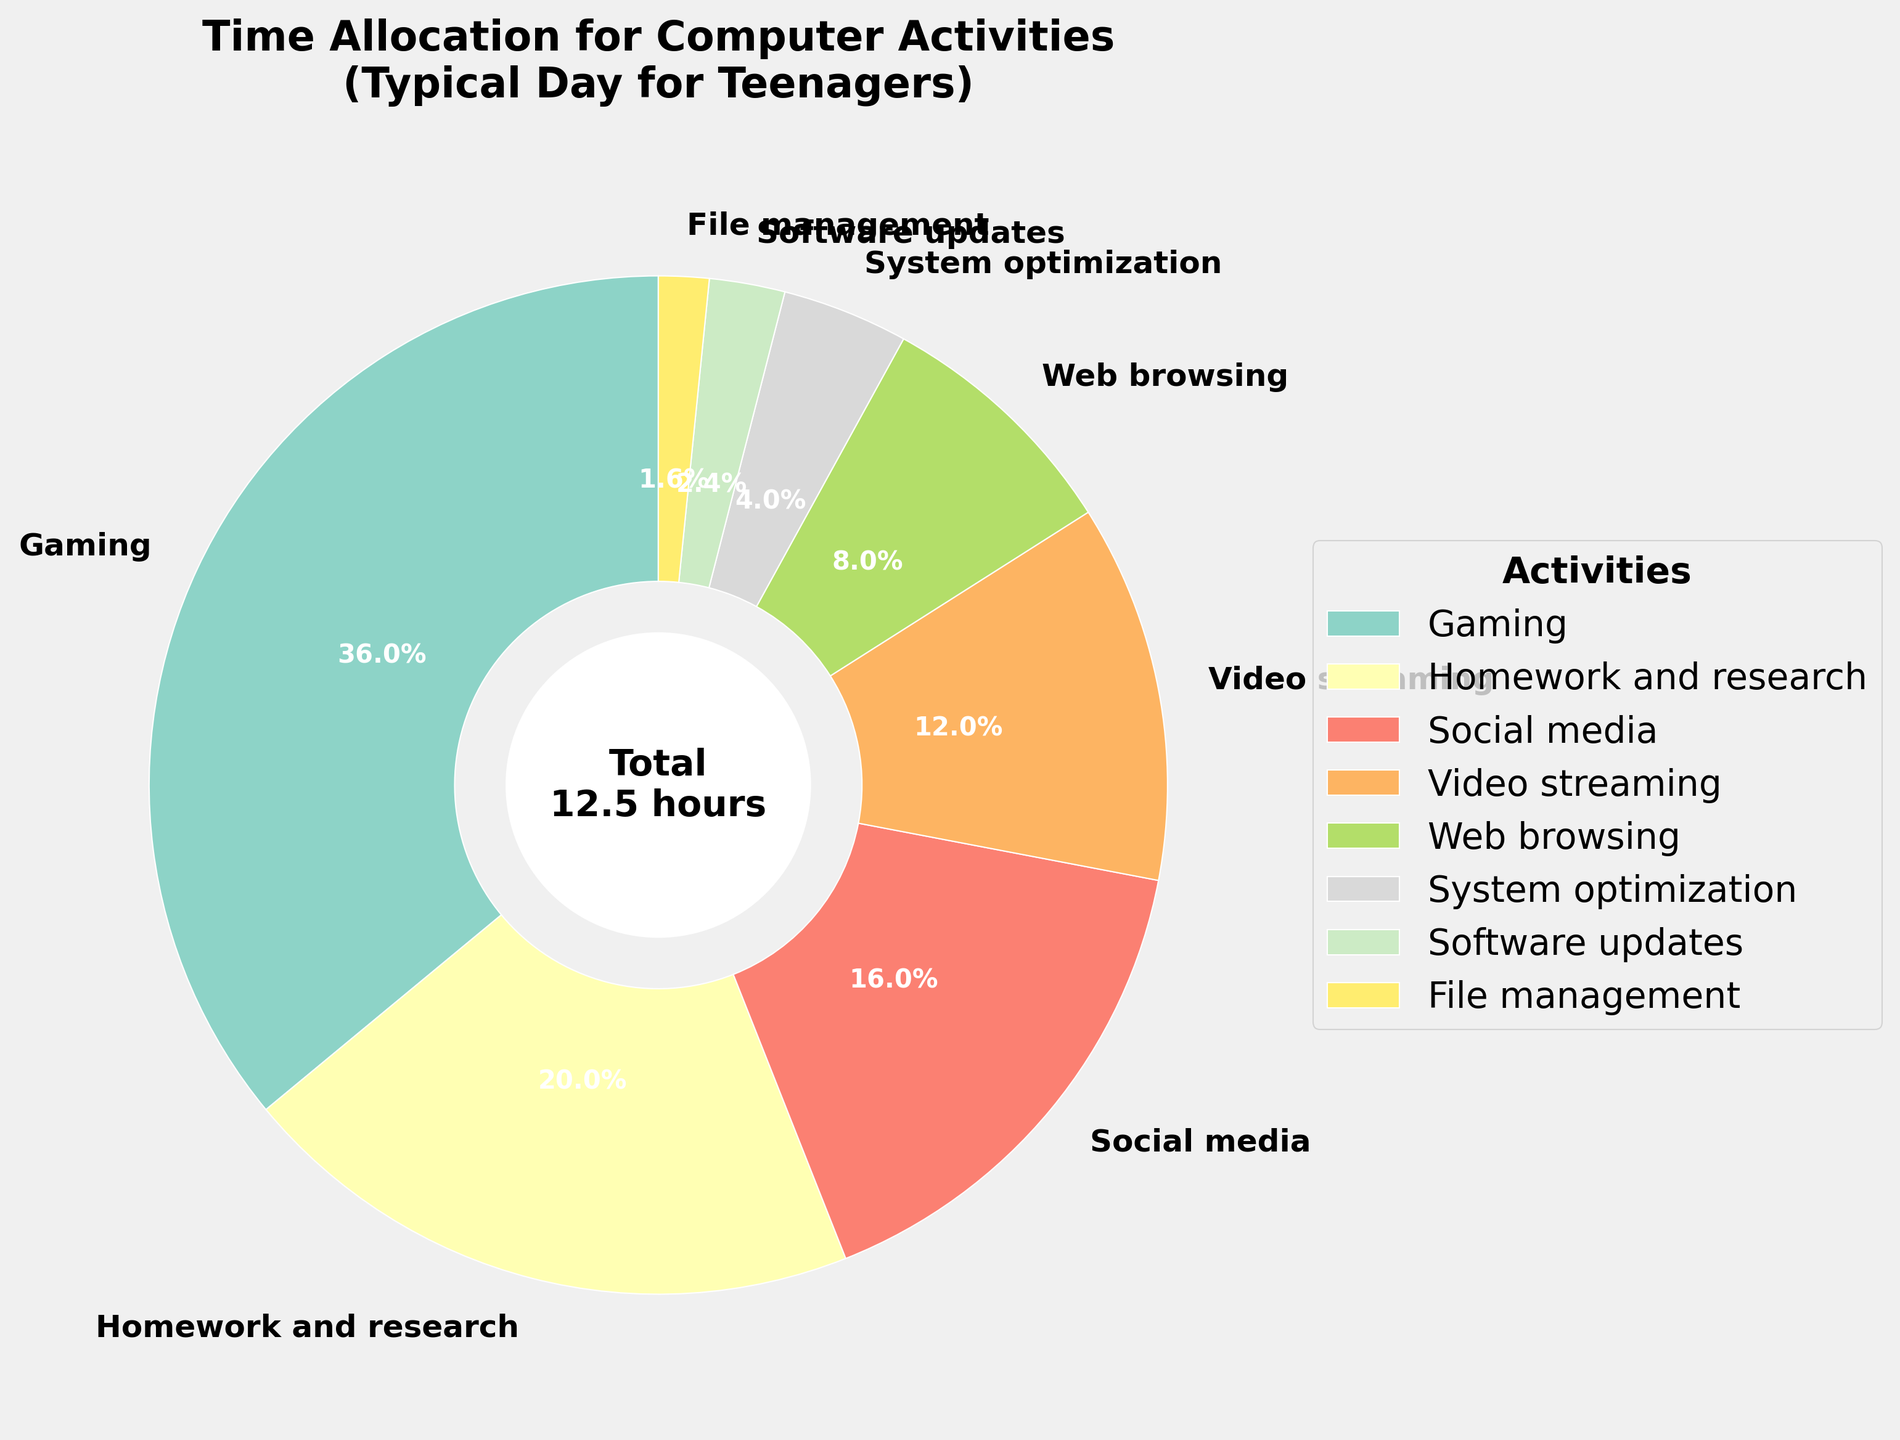Which activity takes up the most amount of time? According to the chart, "Gaming" is the largest wedge, indicating it occupies the most time.
Answer: Gaming How much time in total is spent on activities excluding gaming? Sum the hours of all activities excluding gaming: 2.5 (Homework) + 2 (Social media) + 1.5 (Video streaming) + 1 (Web browsing) + 0.5 (System optimization) + 0.3 (Software updates) + 0.2 (File management) = 8 hours
Answer: 8 hours Which takes more time, social media or video streaming? Comparing the wedges for "Social media" and "Video streaming", social media is larger.
Answer: Social media What percentage of the day is spent on homework and research? The wedge for "Homework and research" shows a percentage, which is 2.5/10.5 hours * 100 = 23.8%.
Answer: 23.8% Is more time spent on file management or software updates? File management has a smaller wedge than software updates, so less time is spent on file management.
Answer: Software updates How much more time is spent on gaming compared to system optimization? Subtract the hours for system optimization from gaming: 4.5 - 0.5 = 4 hours more.
Answer: 4 hours Are gaming and homework combined more than half of the total time? Combine the hours for gaming and homework: 4.5 + 2.5 = 7. 7/10.5 hours is about 66.7%, which is more than half.
Answer: Yes Which activities together make up less than 1 hour? "Software updates" (0.3 hours) and "File management" (0.2 hours) together make 0.3 + 0.2 = 0.5 hours.
Answer: Software updates and File management What percentage of the time is spent on system-oriented tasks (optimization, updates, file management)? Combine hours for system optimization, software updates, file management: 0.5 + 0.3 + 0.2 = 1 hour. 1/10.5 * 100% = 9.5%.
Answer: 9.5% 